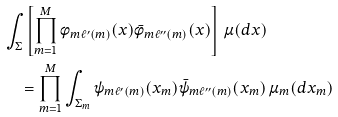<formula> <loc_0><loc_0><loc_500><loc_500>& \int _ { \Sigma } \left [ \prod _ { m = 1 } ^ { M } \phi _ { m \ell ^ { \prime } ( m ) } ( x ) \bar { \phi } _ { m \ell ^ { \prime \prime } ( m ) } ( x ) \right ] \, \mu ( d x ) \\ & \quad = \prod _ { m = 1 } ^ { M } \int _ { \Sigma _ { m } } \psi _ { m \ell ^ { \prime } ( m ) } ( x _ { m } ) \bar { \psi } _ { m \ell ^ { \prime \prime } ( m ) } ( x _ { m } ) \, \mu _ { m } ( d x _ { m } ) \\</formula> 